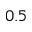<formula> <loc_0><loc_0><loc_500><loc_500>0 . 5</formula> 